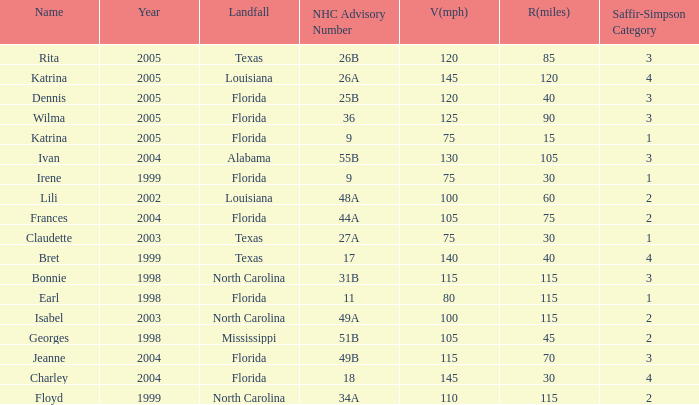Which landfall was in category 1 for Saffir-Simpson in 1999? Florida. 